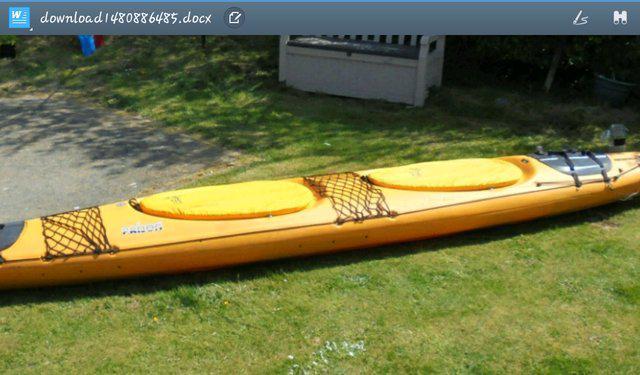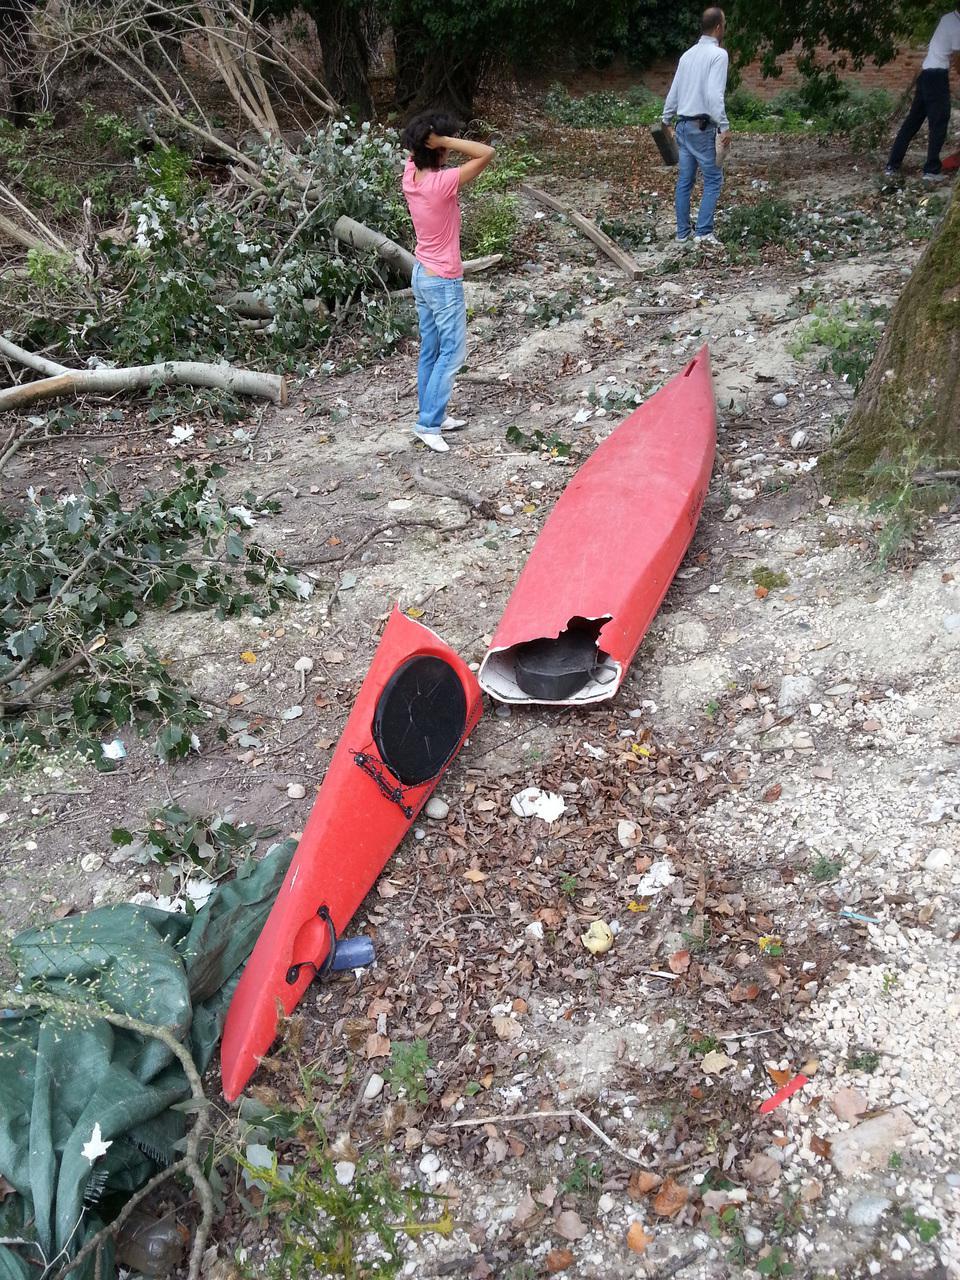The first image is the image on the left, the second image is the image on the right. For the images shown, is this caption "there is an oar laying across the boat" true? Answer yes or no. No. The first image is the image on the left, the second image is the image on the right. Examine the images to the left and right. Is the description "The canoe is facing left in both images." accurate? Answer yes or no. No. 